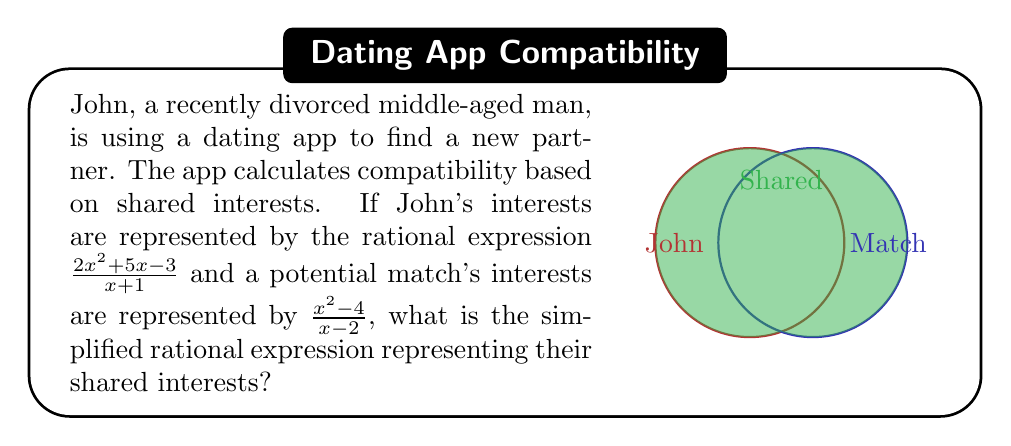Show me your answer to this math problem. To find the shared interests, we need to multiply the two rational expressions:

1) First, let's multiply the numerators and denominators separately:
   $$\frac{2x^2 + 5x - 3}{x + 1} \cdot \frac{x^2 - 4}{x - 2}$$
   
   Numerator: $(2x^2 + 5x - 3)(x^2 - 4)$
   Denominator: $(x + 1)(x - 2)$

2) Expand the numerator:
   $(2x^2 + 5x - 3)(x^2 - 4) = 2x^4 - 8x^2 + 5x^3 - 20x - 3x^2 + 12$
                              $= 2x^4 + 5x^3 - 11x^2 - 20x + 12$

3) Factor the denominator:
   $(x + 1)(x - 2) = x^2 - x - 2$

4) Our rational expression is now:
   $$\frac{2x^4 + 5x^3 - 11x^2 - 20x + 12}{x^2 - x - 2}$$

5) This is already in its simplest form as there are no common factors between the numerator and denominator.
Answer: $$\frac{2x^4 + 5x^3 - 11x^2 - 20x + 12}{x^2 - x - 2}$$ 